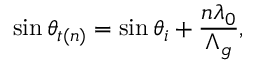Convert formula to latex. <formula><loc_0><loc_0><loc_500><loc_500>\sin \theta _ { t ( n ) } = \sin \theta _ { i } + \frac { n \lambda _ { 0 } } { \Lambda _ { g } } ,</formula> 